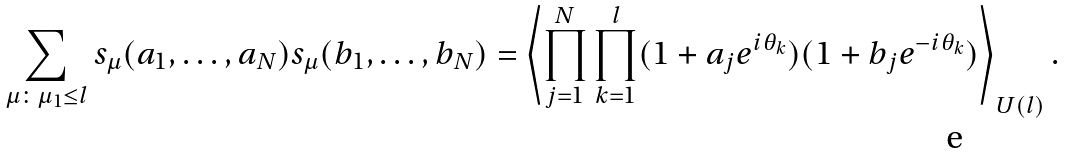<formula> <loc_0><loc_0><loc_500><loc_500>\sum _ { \mu \colon \mu _ { 1 } \leq l } s _ { \mu } ( a _ { 1 } , \dots , a _ { N } ) s _ { \mu } ( b _ { 1 } , \dots , b _ { N } ) = \left \langle \prod _ { j = 1 } ^ { N } \prod _ { k = 1 } ^ { l } ( 1 + a _ { j } e ^ { i \theta _ { k } } ) ( 1 + b _ { j } e ^ { - i \theta _ { k } } ) \right \rangle _ { U ( l ) } .</formula> 